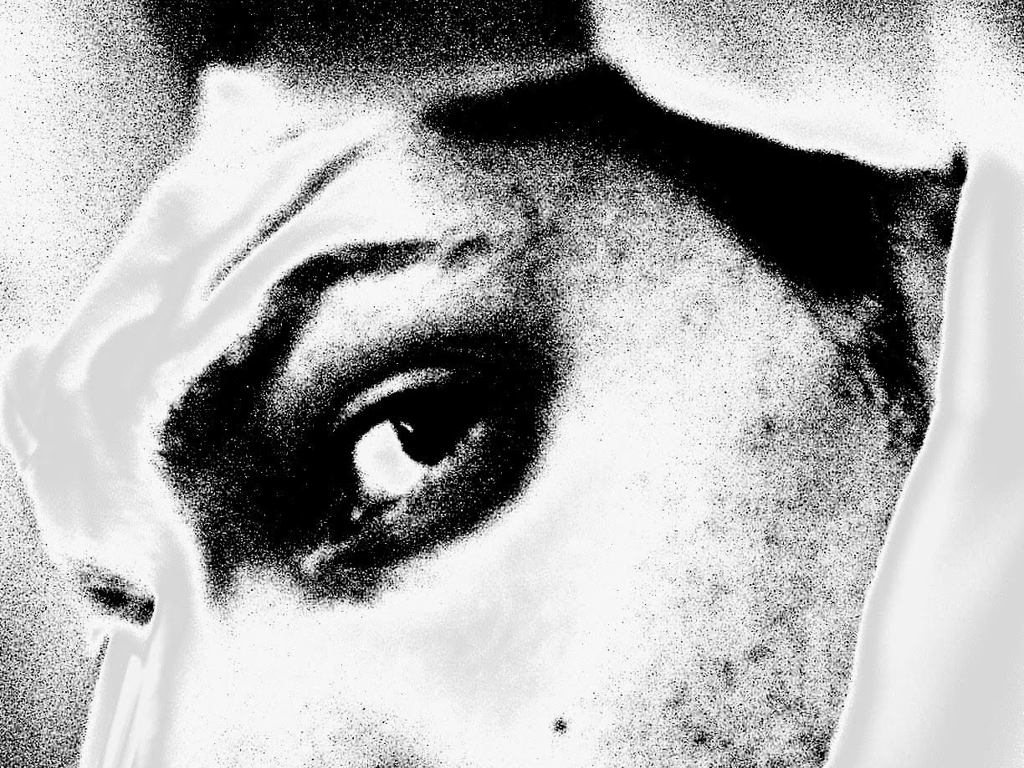Does the image have a smooth texture? The image presents a high-contrast texture with pronounced shadows and highlights, resulting in a visual effect that appears more gritty than smooth. The texture showcases a stippled effect and lacks the uniformity typically associated with smooth textures. 